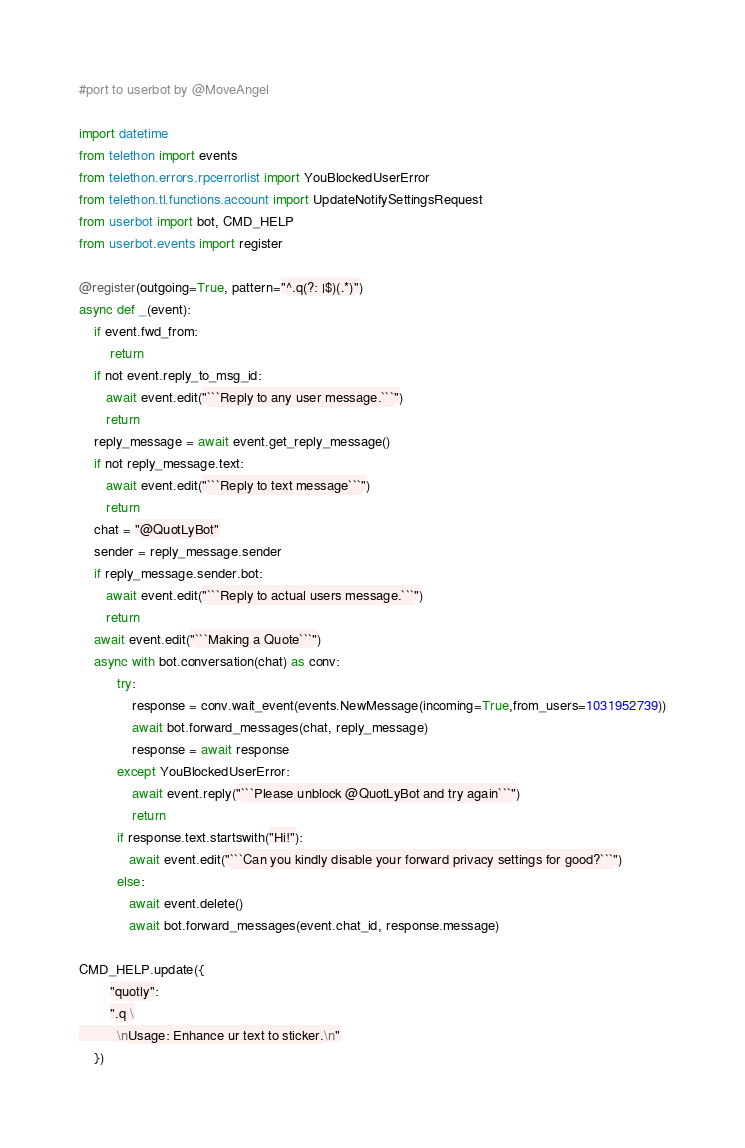Convert code to text. <code><loc_0><loc_0><loc_500><loc_500><_Python_>#port to userbot by @MoveAngel

import datetime
from telethon import events
from telethon.errors.rpcerrorlist import YouBlockedUserError
from telethon.tl.functions.account import UpdateNotifySettingsRequest
from userbot import bot, CMD_HELP
from userbot.events import register

@register(outgoing=True, pattern="^.q(?: |$)(.*)")
async def _(event):
    if event.fwd_from:
        return
    if not event.reply_to_msg_id:
       await event.edit("```Reply to any user message.```")
       return
    reply_message = await event.get_reply_message()
    if not reply_message.text:
       await event.edit("```Reply to text message```")
       return
    chat = "@QuotLyBot"
    sender = reply_message.sender
    if reply_message.sender.bot:
       await event.edit("```Reply to actual users message.```")
       return
    await event.edit("```Making a Quote```")
    async with bot.conversation(chat) as conv:
          try:
              response = conv.wait_event(events.NewMessage(incoming=True,from_users=1031952739))
              await bot.forward_messages(chat, reply_message)
              response = await response
          except YouBlockedUserError:
              await event.reply("```Please unblock @QuotLyBot and try again```")
              return
          if response.text.startswith("Hi!"):
             await event.edit("```Can you kindly disable your forward privacy settings for good?```")
          else:
             await event.delete()
             await bot.forward_messages(event.chat_id, response.message)

CMD_HELP.update({
        "quotly":
        ".q \
          \nUsage: Enhance ur text to sticker.\n"
    })
</code> 